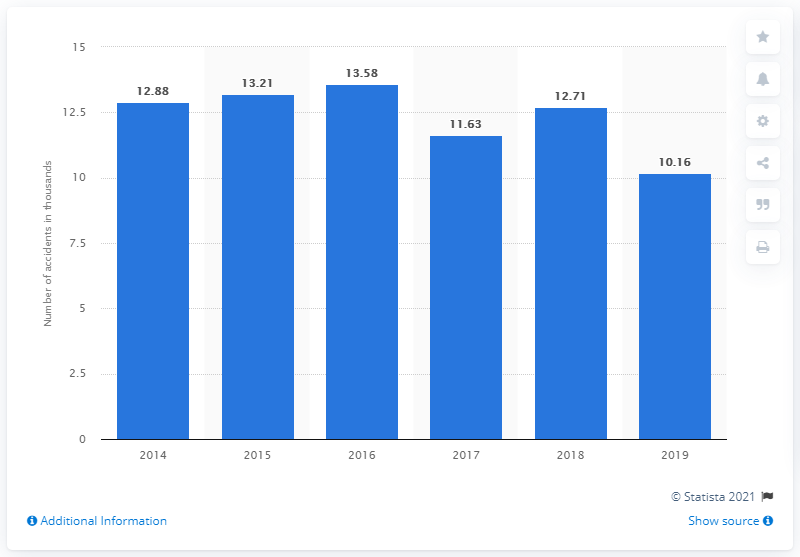Highlight a few significant elements in this photo. According to data from 2015, there were 13.21 road accidents. In the years 2017 and 2019, the number of road accidents was less than 11,000. 